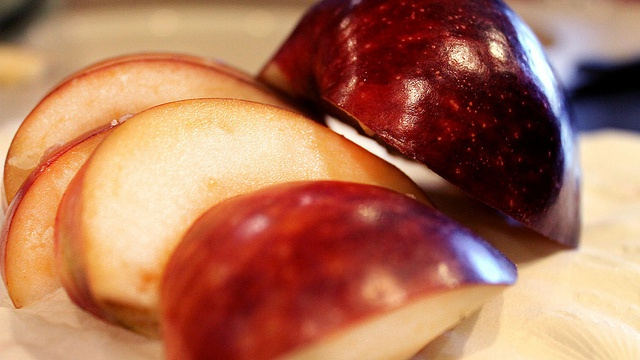Describe the objects in this image and their specific colors. I can see apple in gray, tan, orange, beige, and red tones, apple in gray, brown, maroon, tan, and red tones, apple in gray, maroon, black, and lightgray tones, and dining table in gray, tan, beige, and darkgray tones in this image. 